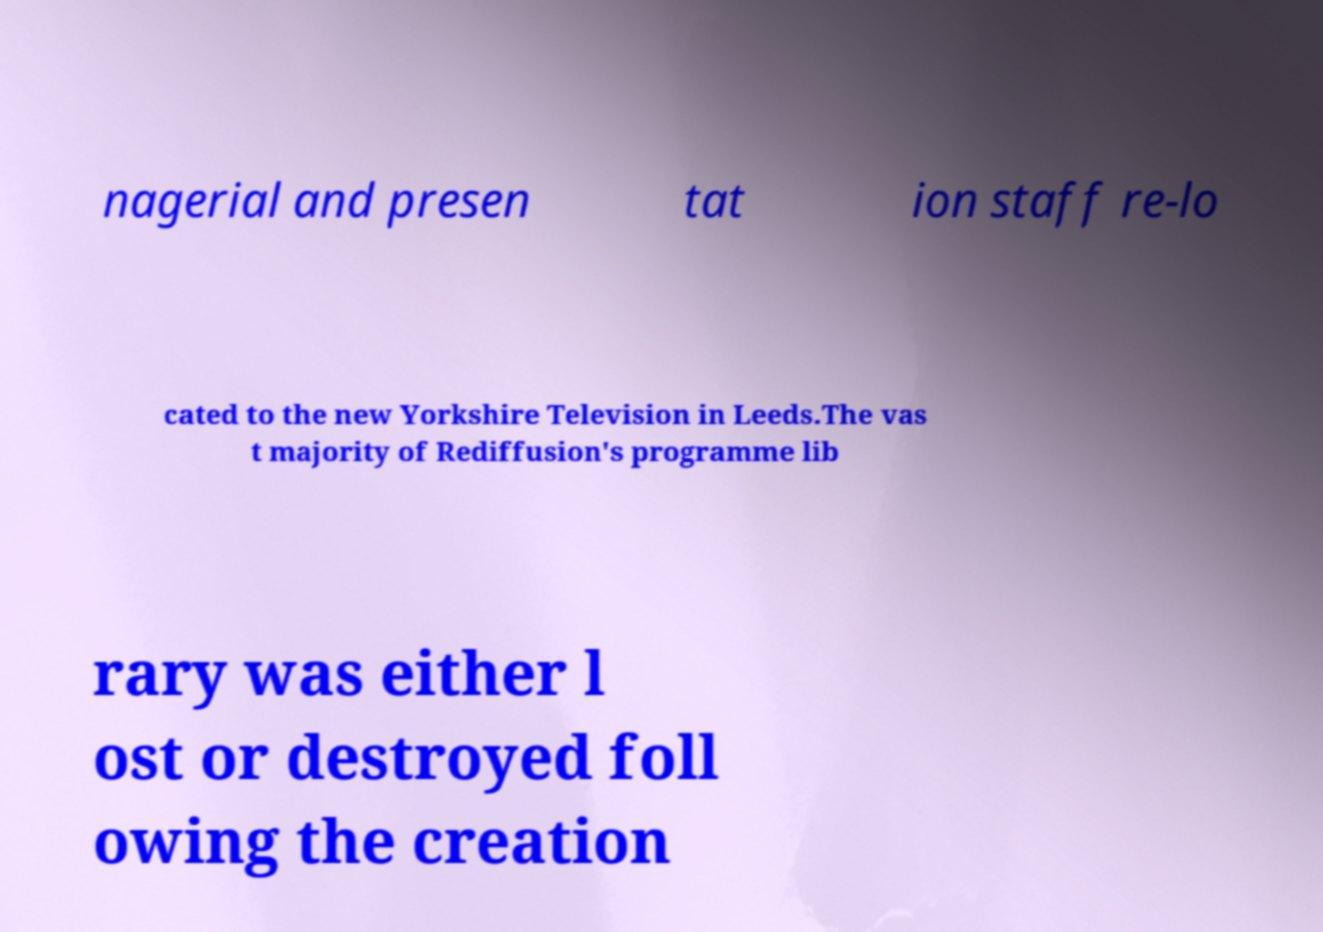Could you extract and type out the text from this image? nagerial and presen tat ion staff re-lo cated to the new Yorkshire Television in Leeds.The vas t majority of Rediffusion's programme lib rary was either l ost or destroyed foll owing the creation 